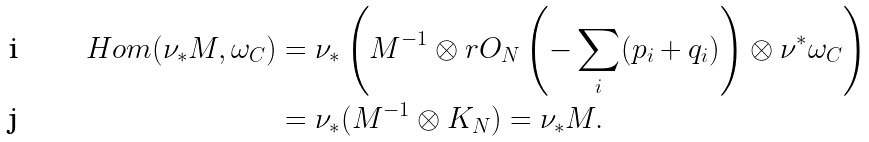<formula> <loc_0><loc_0><loc_500><loc_500>H o m ( \nu _ { * } M , \omega _ { C } ) & = \nu _ { * } \left ( M ^ { - 1 } \otimes r O _ { N } \left ( - \sum _ { i } ( p _ { i } + q _ { i } ) \right ) \otimes \nu ^ { * } \omega _ { C } \right ) \\ & = \nu _ { * } ( M ^ { - 1 } \otimes K _ { N } ) = \nu _ { * } M .</formula> 